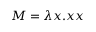<formula> <loc_0><loc_0><loc_500><loc_500>M = \lambda x . x x</formula> 